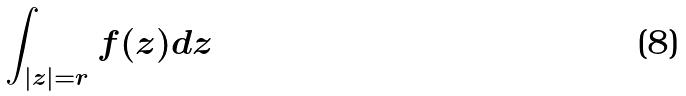Convert formula to latex. <formula><loc_0><loc_0><loc_500><loc_500>\int _ { | z | = r } f ( z ) d z</formula> 